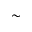<formula> <loc_0><loc_0><loc_500><loc_500>\sim</formula> 